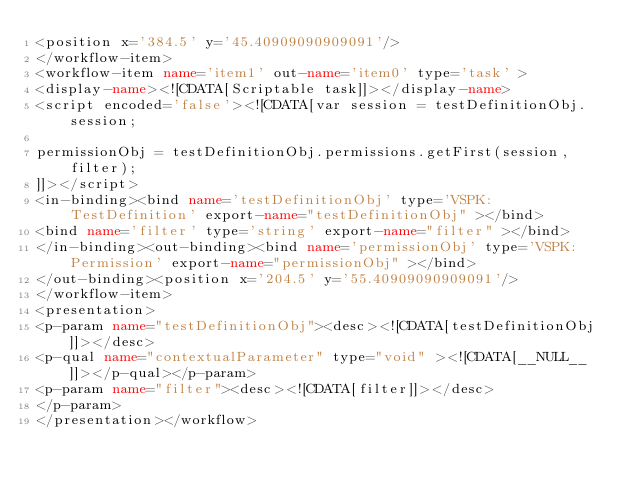<code> <loc_0><loc_0><loc_500><loc_500><_XML_><position x='384.5' y='45.40909090909091'/>
</workflow-item>
<workflow-item name='item1' out-name='item0' type='task' >
<display-name><![CDATA[Scriptable task]]></display-name>
<script encoded='false'><![CDATA[var session = testDefinitionObj.session;

permissionObj = testDefinitionObj.permissions.getFirst(session, filter);
]]></script>
<in-binding><bind name='testDefinitionObj' type='VSPK:TestDefinition' export-name="testDefinitionObj" ></bind>
<bind name='filter' type='string' export-name="filter" ></bind>
</in-binding><out-binding><bind name='permissionObj' type='VSPK:Permission' export-name="permissionObj" ></bind>
</out-binding><position x='204.5' y='55.40909090909091'/>
</workflow-item>
<presentation>
<p-param name="testDefinitionObj"><desc><![CDATA[testDefinitionObj]]></desc>
<p-qual name="contextualParameter" type="void" ><![CDATA[__NULL__]]></p-qual></p-param>
<p-param name="filter"><desc><![CDATA[filter]]></desc>
</p-param>
</presentation></workflow></code> 